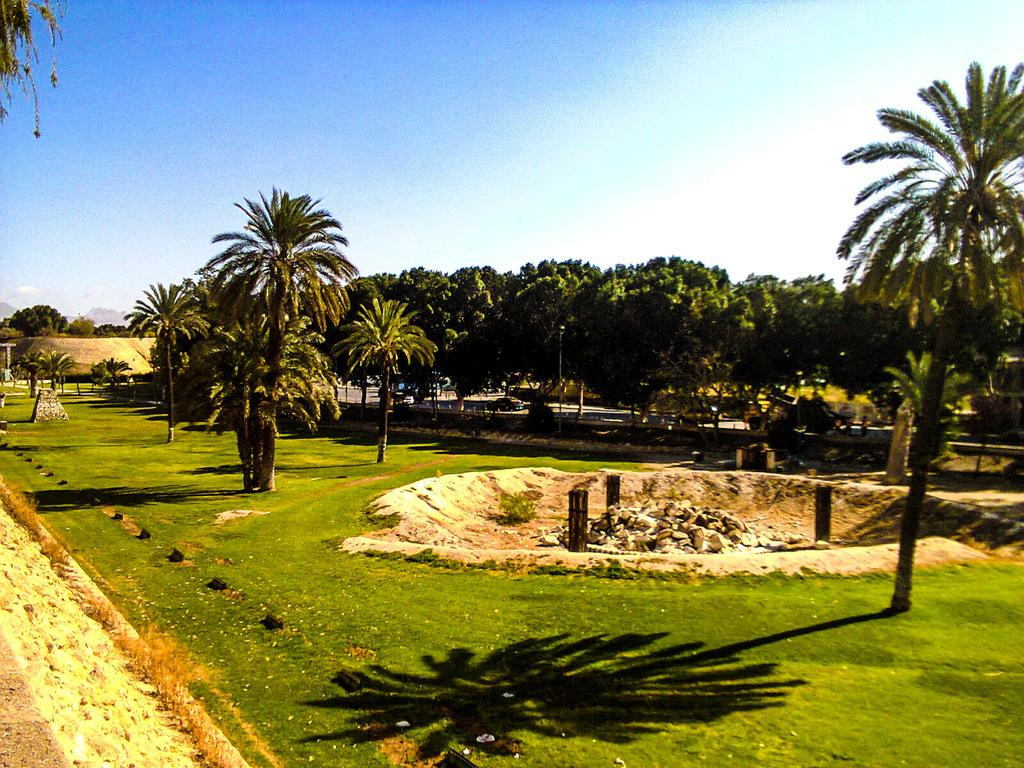What type of surface is visible in the image? The image contains a grass surface. What type of vegetation can be seen in the image? There are trees in the image. What is visible in the background of the image? The background of the image includes trees and the sky. What type of jelly can be seen on the grass in the image? There is no jelly present on the grass in the image. How does the wave affect the trees in the image? There is no wave present in the image, so it cannot affect the trees. 